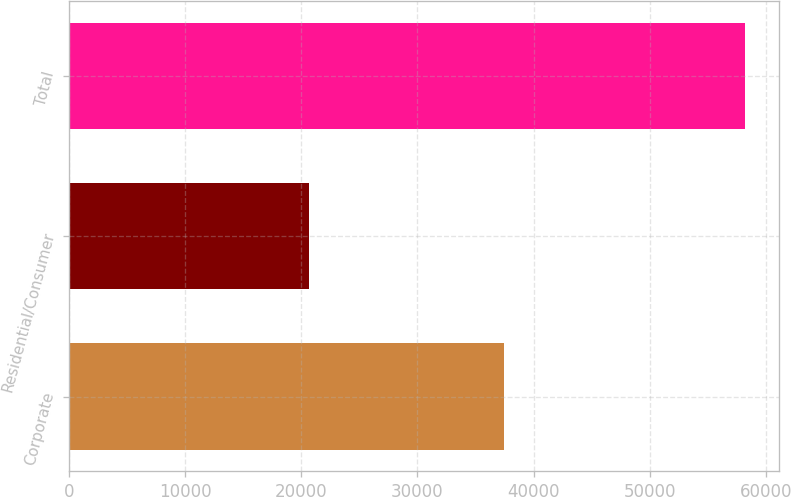Convert chart. <chart><loc_0><loc_0><loc_500><loc_500><bar_chart><fcel>Corporate<fcel>Residential/Consumer<fcel>Total<nl><fcel>37462<fcel>20702<fcel>58164<nl></chart> 